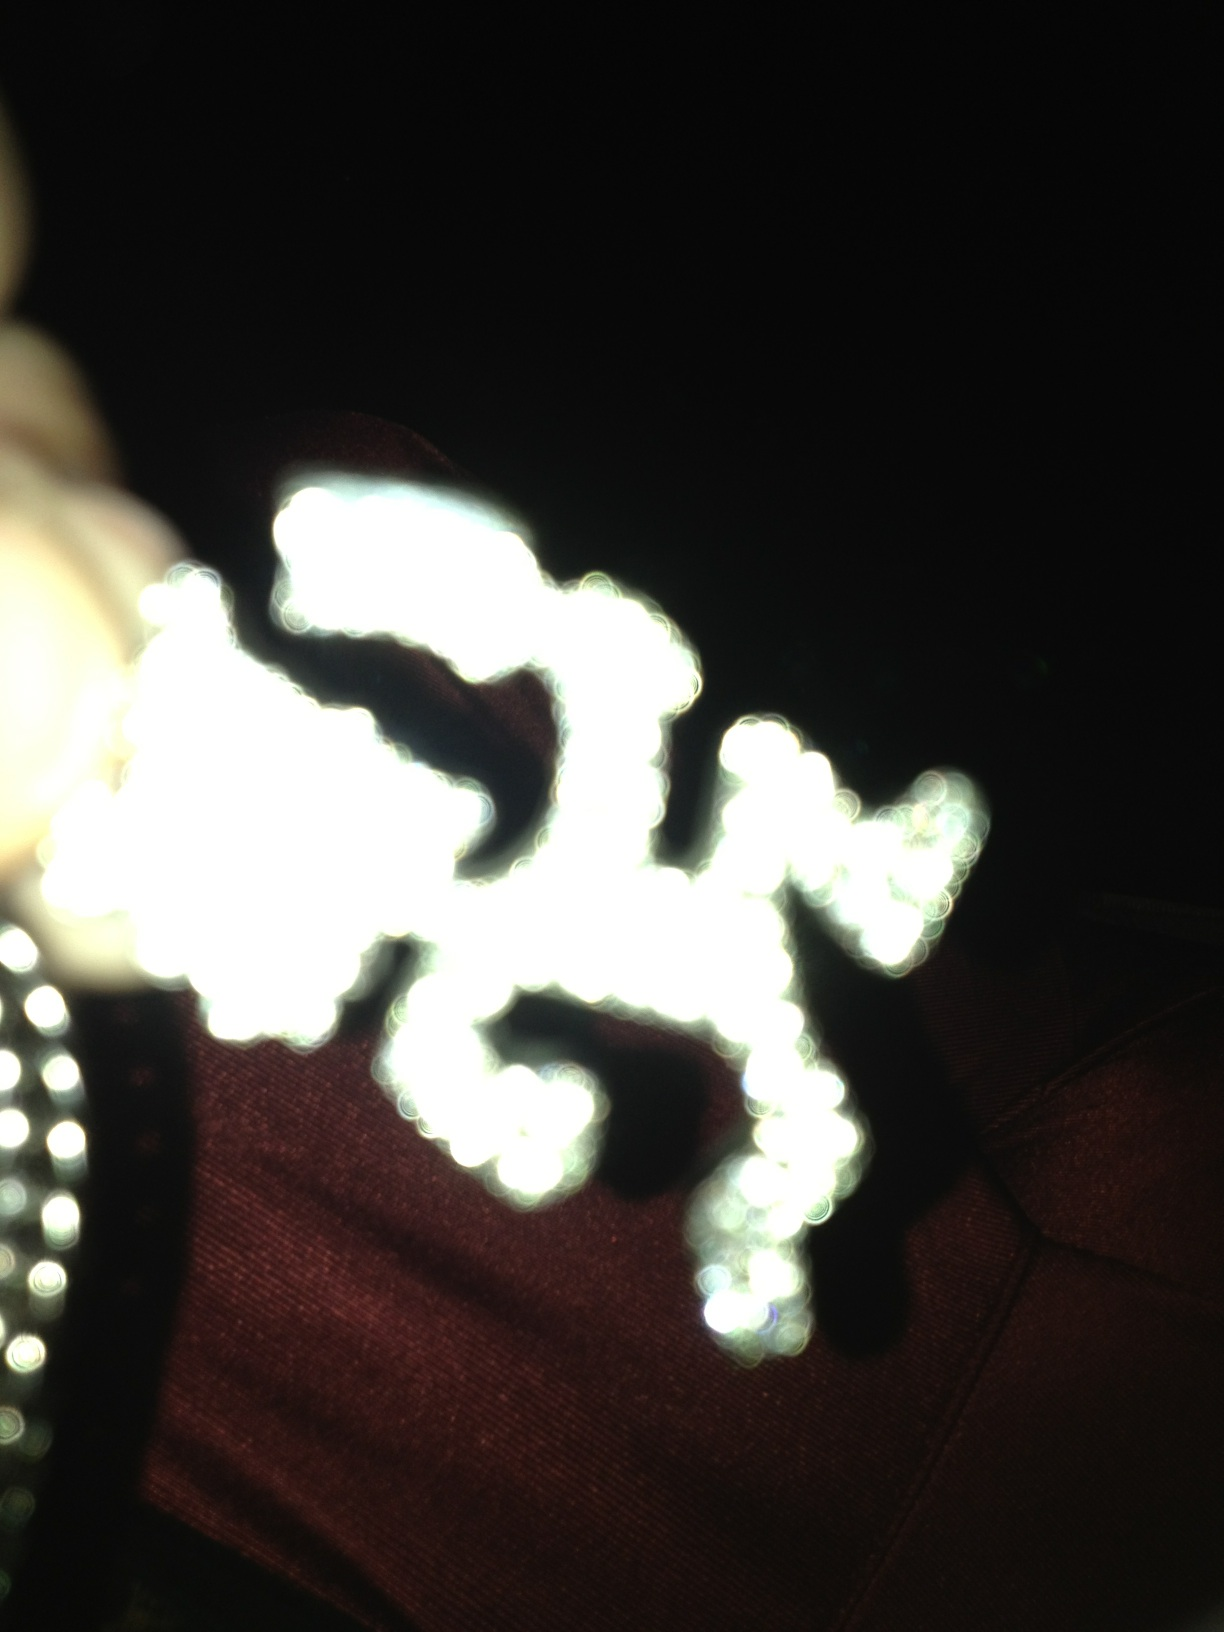Is this acceptable to wear in public? The image is too blurred to identify what specific item is being questioned for public acceptability. An item's appropriateness for public wear usually depends on various factors such as local cultural norms and the specific context in which it will be worn. For more specific advice, a clearer image or additional details would be helpful. 